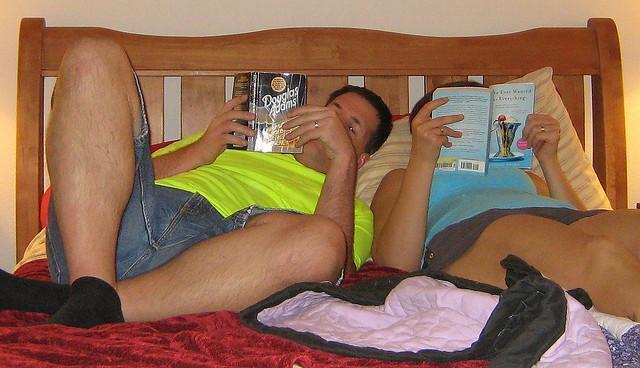How many people can you see?
Give a very brief answer. 2. How many books are in the photo?
Give a very brief answer. 2. How many elephants are in the picture?
Give a very brief answer. 0. 